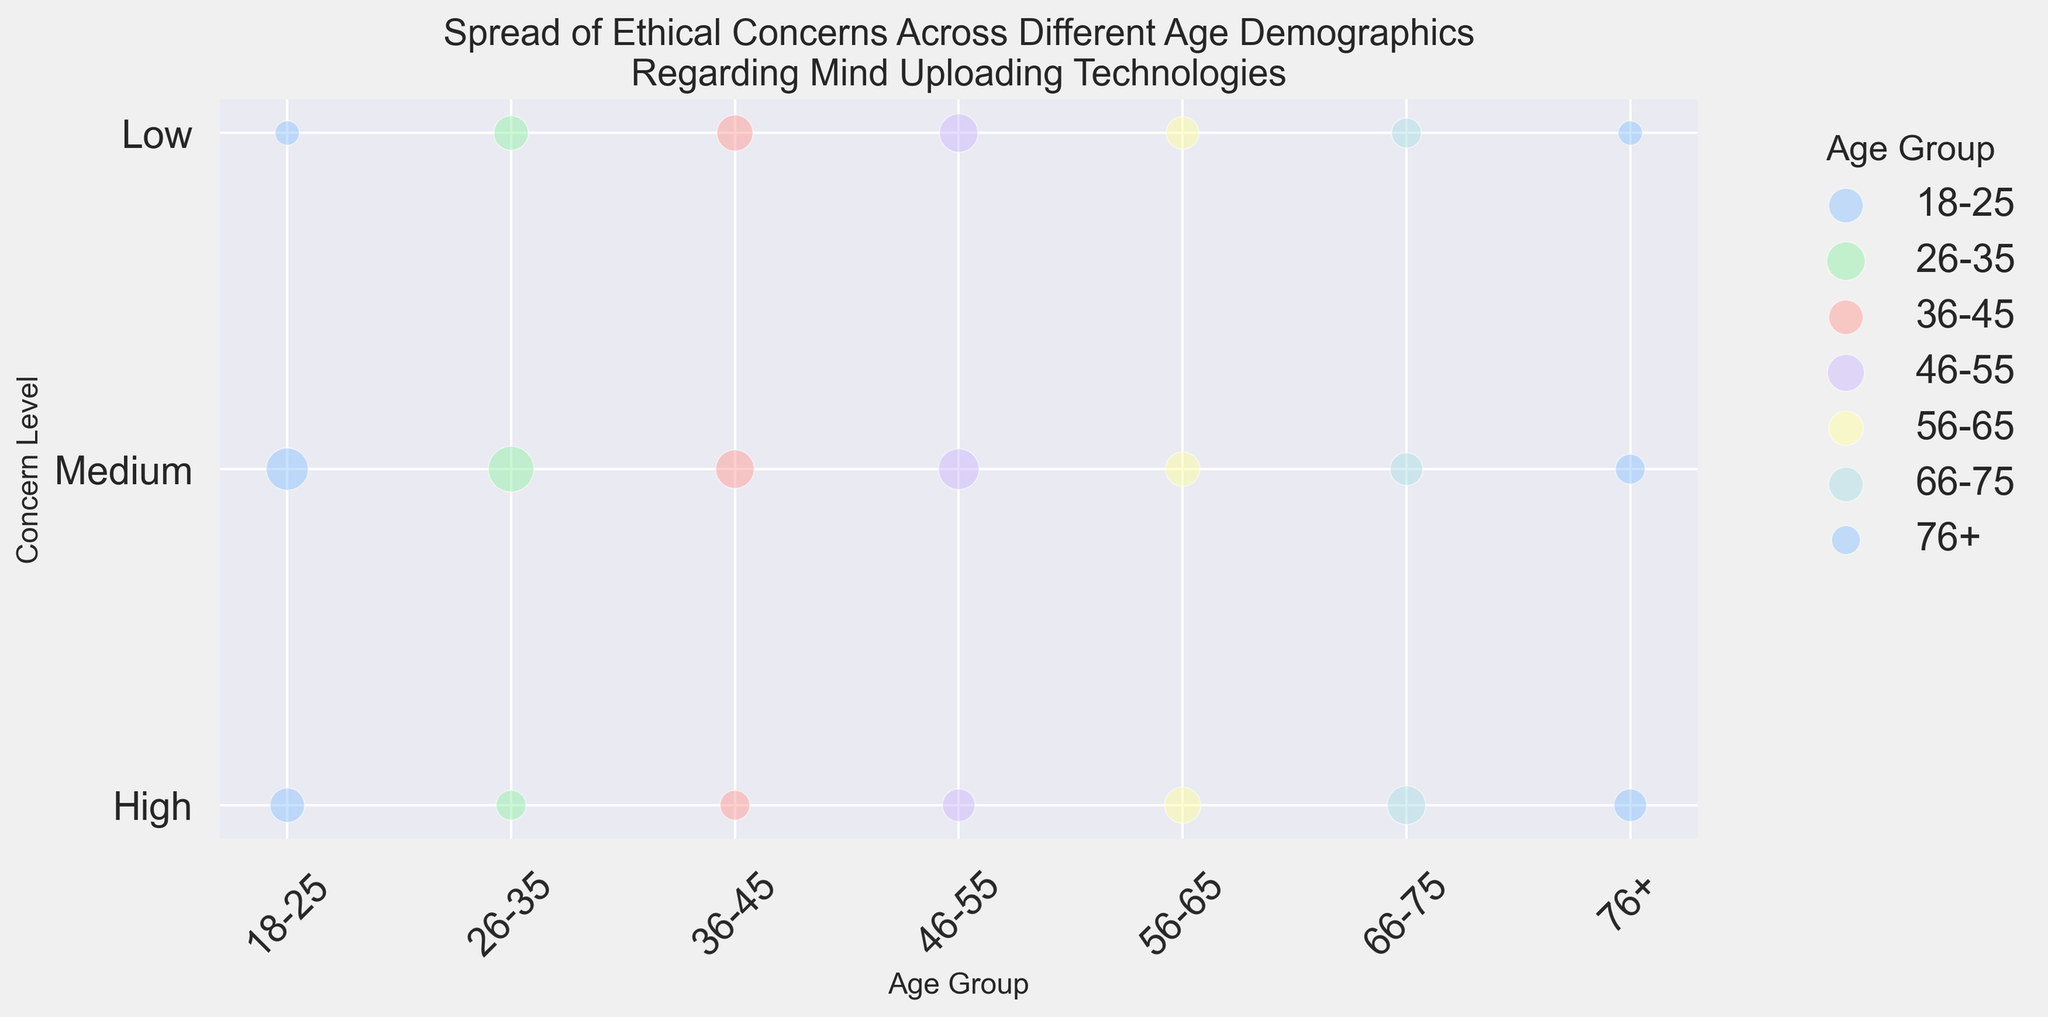What age group has the highest level of concern (High) regarding mind uploading technologies? In the figure, the age group with the largest bubble at the 'High' concern level would represent the highest level of concern. The 'High' concern level bubble for the age group 66-75 has a size of 25, which is the largest.
Answer: 66-75 Which age group shows the largest bubble size for medium concern levels? By examining the 'Medium' concern level row in the figure, we identify the age group with the largest bubble. The age group 26-35 has the largest bubble size of 35 for the medium concern level.
Answer: 26-35 Comparing High and Low concern levels, which age group has a greater number of respondents with Low concern? The bubble sizes for 'Low' concern levels need to be compared against those for 'High' concern levels within each age group. The age group 36-45 has a bubble size of 22 for 'Low' concern, which is greater than the bubble size for 'High' concern in the same age group, which is 15.
Answer: 36-45 Which age group has the smallest bubble size for Low concern? By identifying the smallest bubble among the 'Low' concern row, we find that the 76+ age group has the smallest bubble size of 10 at the low concern level.
Answer: 76+ What is the total number of respondents for the age group 46-55 across all concern levels? Sum the number of respondents for each concern level in the 46-55 age group: 80 (high) + 140 (medium) + 200 (low) = 420.
Answer: 420 How does the number of respondents with medium concern in the 18-25 age group compare to those with medium concern in the 56-65 age group? Compare the numbers directly: The 18-25 group has 180 respondents with medium concern, while the 56-65 group has 100 respondents with medium concern.
Answer: 18-25 has more respondents What is the difference in the number of respondents between high and low concern levels for the age group 66-75? Calculate the difference: For the age group 66-75, the number of respondents with high concern is 130, and with low concern it is 80. The difference is 130 - 80 = 50.
Answer: 50 Which concern level (High, Medium, Low) has the smallest average bubble size across all age groups? Calculate the average bubble size for each concern level: (120 + 90 + 70 + 80 + 110 + 130 + 80) / 7 = 97 for High, (180 + 210 + 150 + 140 + 100 + 70 + 50) / 7 = 128 for Medium, (100 + 160 + 180 + 200 + 150 + 80 + 60) / 7 = 133 for Low. The smallest average bubble size is 97, which is for the High concern level.
Answer: High 